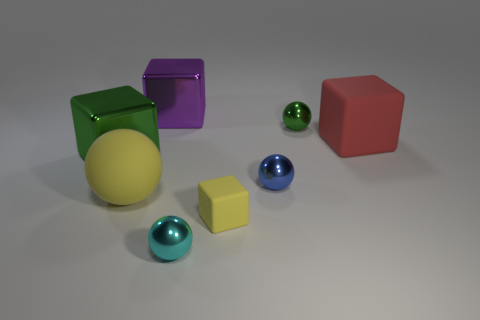What material is the yellow ball that is the same size as the red block?
Your answer should be very brief. Rubber. Is there a tiny cyan object made of the same material as the small yellow cube?
Your answer should be very brief. No. There is a large purple metallic object; does it have the same shape as the shiny thing left of the purple object?
Provide a succinct answer. Yes. How many things are to the right of the big purple cube and in front of the red object?
Your answer should be compact. 3. Are the green ball and the large object in front of the green cube made of the same material?
Your answer should be very brief. No. Are there an equal number of metal cubes that are to the right of the cyan metallic ball and metallic balls?
Provide a succinct answer. No. There is a large thing on the right side of the cyan shiny object; what color is it?
Make the answer very short. Red. What number of other things are the same color as the small matte thing?
Provide a short and direct response. 1. Does the metal block that is behind the green cube have the same size as the small blue metallic thing?
Your answer should be very brief. No. There is a yellow thing to the right of the large purple shiny block; what is its material?
Ensure brevity in your answer.  Rubber. 